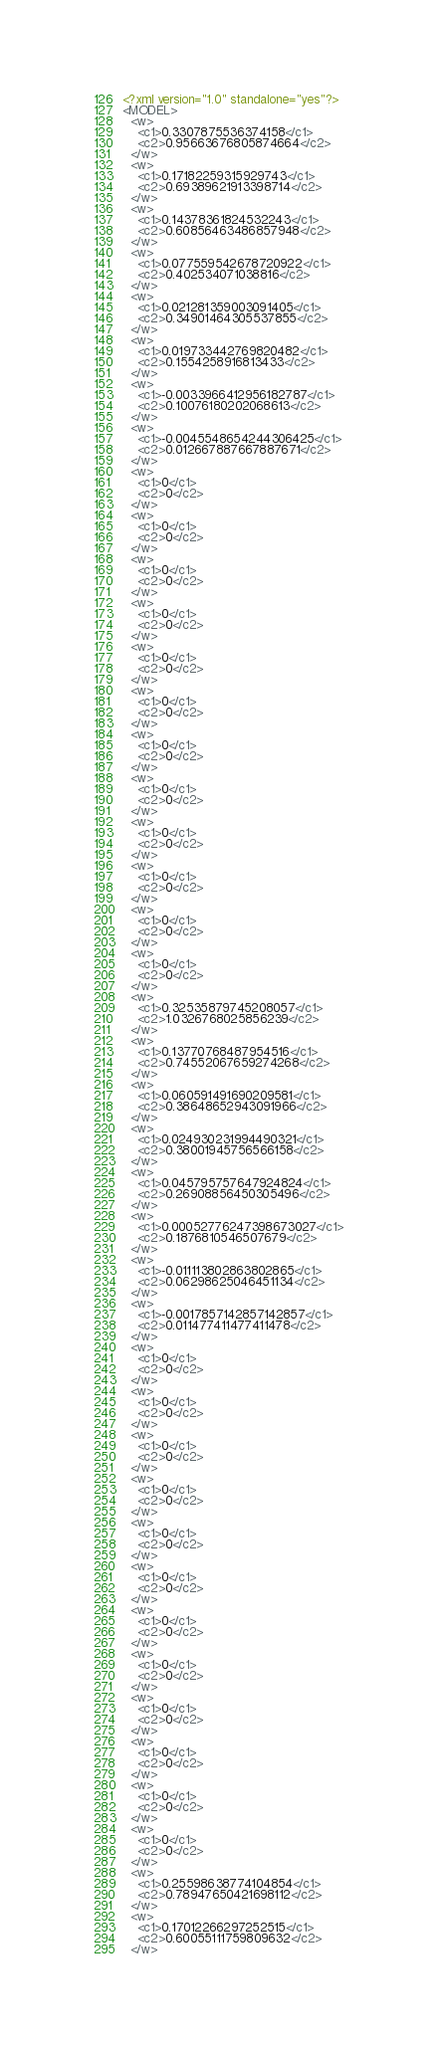<code> <loc_0><loc_0><loc_500><loc_500><_XML_><?xml version="1.0" standalone="yes"?>
<MODEL>
  <w>
    <c1>0.3307875536374158</c1>
    <c2>0.95663676805874664</c2>
  </w>
  <w>
    <c1>0.17182259315929743</c1>
    <c2>0.69389621913398714</c2>
  </w>
  <w>
    <c1>0.14378361824532243</c1>
    <c2>0.60856463486857948</c2>
  </w>
  <w>
    <c1>0.077559542678720922</c1>
    <c2>0.402534071038816</c2>
  </w>
  <w>
    <c1>0.021281359003091405</c1>
    <c2>0.34901464305537855</c2>
  </w>
  <w>
    <c1>0.019733442769820482</c1>
    <c2>0.1554258916813433</c2>
  </w>
  <w>
    <c1>-0.0033966412956182787</c1>
    <c2>0.10076180202068613</c2>
  </w>
  <w>
    <c1>-0.0045548654244306425</c1>
    <c2>0.012667887667887671</c2>
  </w>
  <w>
    <c1>0</c1>
    <c2>0</c2>
  </w>
  <w>
    <c1>0</c1>
    <c2>0</c2>
  </w>
  <w>
    <c1>0</c1>
    <c2>0</c2>
  </w>
  <w>
    <c1>0</c1>
    <c2>0</c2>
  </w>
  <w>
    <c1>0</c1>
    <c2>0</c2>
  </w>
  <w>
    <c1>0</c1>
    <c2>0</c2>
  </w>
  <w>
    <c1>0</c1>
    <c2>0</c2>
  </w>
  <w>
    <c1>0</c1>
    <c2>0</c2>
  </w>
  <w>
    <c1>0</c1>
    <c2>0</c2>
  </w>
  <w>
    <c1>0</c1>
    <c2>0</c2>
  </w>
  <w>
    <c1>0</c1>
    <c2>0</c2>
  </w>
  <w>
    <c1>0</c1>
    <c2>0</c2>
  </w>
  <w>
    <c1>0.32535879745208057</c1>
    <c2>1.0326768025856239</c2>
  </w>
  <w>
    <c1>0.13770768487954516</c1>
    <c2>0.74552067659274268</c2>
  </w>
  <w>
    <c1>0.060591491690209581</c1>
    <c2>0.38648652943091966</c2>
  </w>
  <w>
    <c1>0.024930231994490321</c1>
    <c2>0.38001945756566158</c2>
  </w>
  <w>
    <c1>0.045795757647924824</c1>
    <c2>0.26908856450305496</c2>
  </w>
  <w>
    <c1>0.00052776247398673027</c1>
    <c2>0.1876810546507679</c2>
  </w>
  <w>
    <c1>-0.011113802863802865</c1>
    <c2>0.06298625046451134</c2>
  </w>
  <w>
    <c1>-0.0017857142857142857</c1>
    <c2>0.011477411477411478</c2>
  </w>
  <w>
    <c1>0</c1>
    <c2>0</c2>
  </w>
  <w>
    <c1>0</c1>
    <c2>0</c2>
  </w>
  <w>
    <c1>0</c1>
    <c2>0</c2>
  </w>
  <w>
    <c1>0</c1>
    <c2>0</c2>
  </w>
  <w>
    <c1>0</c1>
    <c2>0</c2>
  </w>
  <w>
    <c1>0</c1>
    <c2>0</c2>
  </w>
  <w>
    <c1>0</c1>
    <c2>0</c2>
  </w>
  <w>
    <c1>0</c1>
    <c2>0</c2>
  </w>
  <w>
    <c1>0</c1>
    <c2>0</c2>
  </w>
  <w>
    <c1>0</c1>
    <c2>0</c2>
  </w>
  <w>
    <c1>0</c1>
    <c2>0</c2>
  </w>
  <w>
    <c1>0</c1>
    <c2>0</c2>
  </w>
  <w>
    <c1>0.25598638774104854</c1>
    <c2>0.78947650421698112</c2>
  </w>
  <w>
    <c1>0.17012266297252515</c1>
    <c2>0.60055111759809632</c2>
  </w></code> 